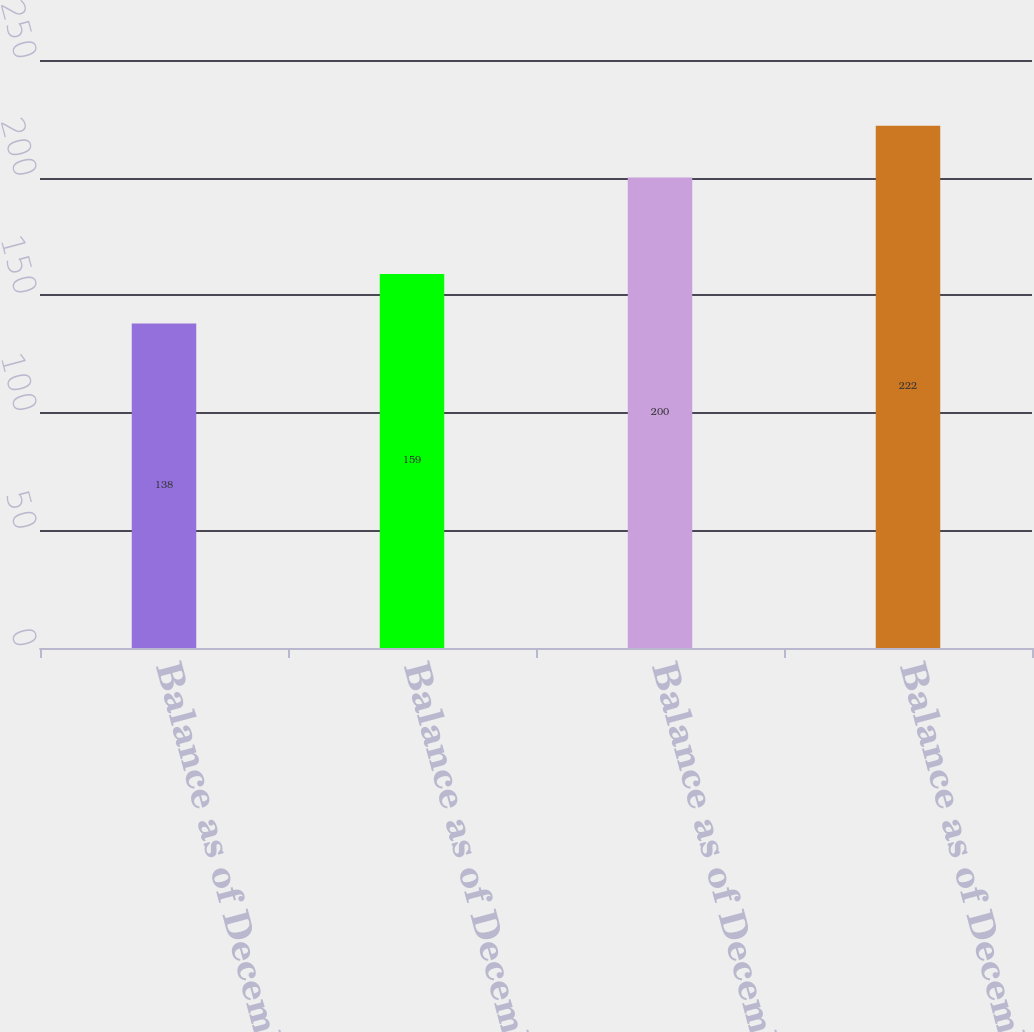Convert chart to OTSL. <chart><loc_0><loc_0><loc_500><loc_500><bar_chart><fcel>Balance as of December 31 2013<fcel>Balance as of December 31 2014<fcel>Balance as of December 31 2015<fcel>Balance as of December 31 2016<nl><fcel>138<fcel>159<fcel>200<fcel>222<nl></chart> 